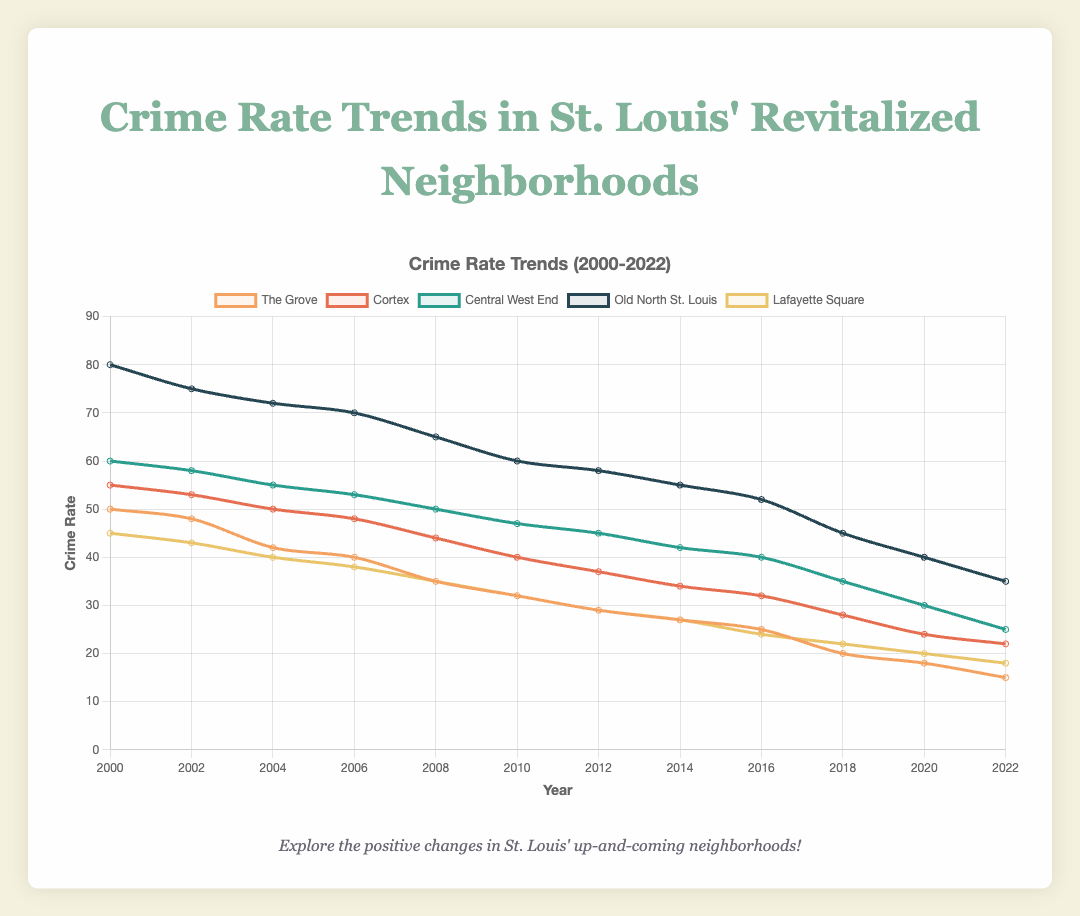What is the overall trend in the crime rate in The Grove from 2000 to 2022? The crime rate in The Grove has consistently decreased over the years from 50 in 2000 to 15 in 2022.
Answer: Decreasing Which neighborhood had the highest crime rate in 2000, and what was the rate? Old North St. Louis had the highest crime rate in 2000, with a rate of 80.
Answer: Old North St. Louis, 80 How much did the crime rate decrease in Central West End from 2000 to 2022? The crime rate decreased from 60 in 2000 to 25 in 2022. The difference is 60 - 25 = 35.
Answer: 35 Among The Grove and Lafayette Square, which neighborhood had a lower crime rate in 2022? In 2022, The Grove had a crime rate of 15, while Lafayette Square had a crime rate of 18. The Grove had a lower crime rate.
Answer: The Grove What was the crime rate in 2010 for Cortex and Central West End, and which was higher? The crime rate in 2010 for Cortex was 40, and for Central West End, it was 47. Central West End had a higher crime rate.
Answer: Central West End In which years did Old North St. Louis have a crime rate below 60? The crime rate in Old North St. Louis was below 60 in the years 2016, 2018, 2020, and 2022.
Answer: 2016, 2018, 2020, 2022 What is the difference between the crime rate in 2020 in Lafayette Square and Central West End? In 2020, the crime rate in Lafayette Square was 20, and in Central West End, it was 30. The difference is 30 - 20 = 10.
Answer: 10 Is the overall trend of crime rates similar across all five neighborhoods? Yes, all five neighborhoods show a decreasing trend in crime rates from 2000 to 2022.
Answer: Yes 